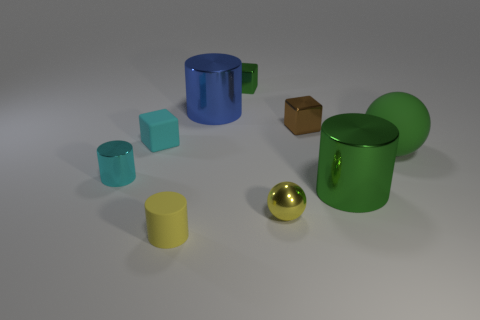Add 1 big blue objects. How many objects exist? 10 Subtract all cubes. How many objects are left? 6 Subtract all rubber blocks. Subtract all cyan shiny cylinders. How many objects are left? 7 Add 4 tiny metallic spheres. How many tiny metallic spheres are left? 5 Add 6 big blue metallic things. How many big blue metallic things exist? 7 Subtract 0 purple spheres. How many objects are left? 9 